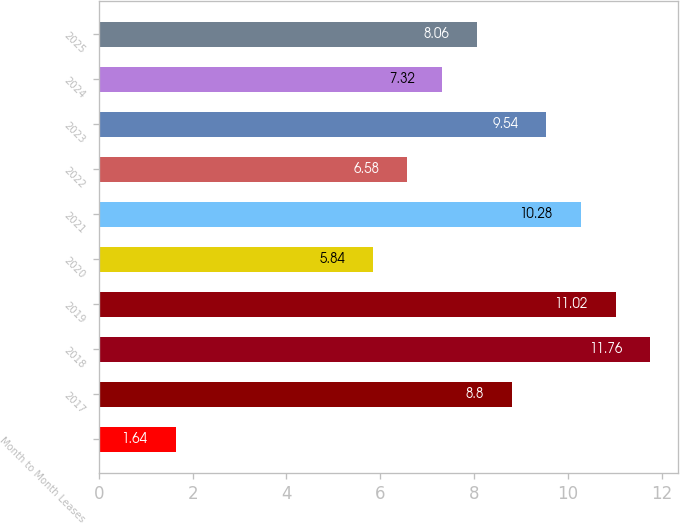<chart> <loc_0><loc_0><loc_500><loc_500><bar_chart><fcel>Month to Month Leases<fcel>2017<fcel>2018<fcel>2019<fcel>2020<fcel>2021<fcel>2022<fcel>2023<fcel>2024<fcel>2025<nl><fcel>1.64<fcel>8.8<fcel>11.76<fcel>11.02<fcel>5.84<fcel>10.28<fcel>6.58<fcel>9.54<fcel>7.32<fcel>8.06<nl></chart> 